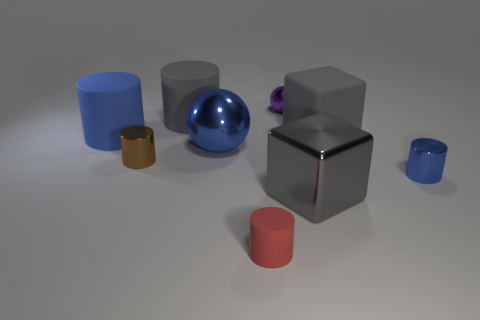Do the tiny purple thing and the big sphere have the same material?
Offer a very short reply. Yes. How many objects are gray metallic cubes or large gray matte objects?
Ensure brevity in your answer.  3. How many other big balls are the same material as the purple ball?
Your answer should be compact. 1. What is the size of the matte object that is the same shape as the big gray shiny object?
Give a very brief answer. Large. There is a small brown metal object; are there any large blue cylinders right of it?
Your answer should be very brief. No. What is the large blue ball made of?
Provide a succinct answer. Metal. There is a cube right of the big gray metallic cube; does it have the same color as the big metal block?
Your answer should be very brief. Yes. What is the color of the other large object that is the same shape as the big gray metal thing?
Give a very brief answer. Gray. What is the material of the blue cylinder right of the small purple object?
Your answer should be very brief. Metal. The small rubber thing is what color?
Ensure brevity in your answer.  Red. 